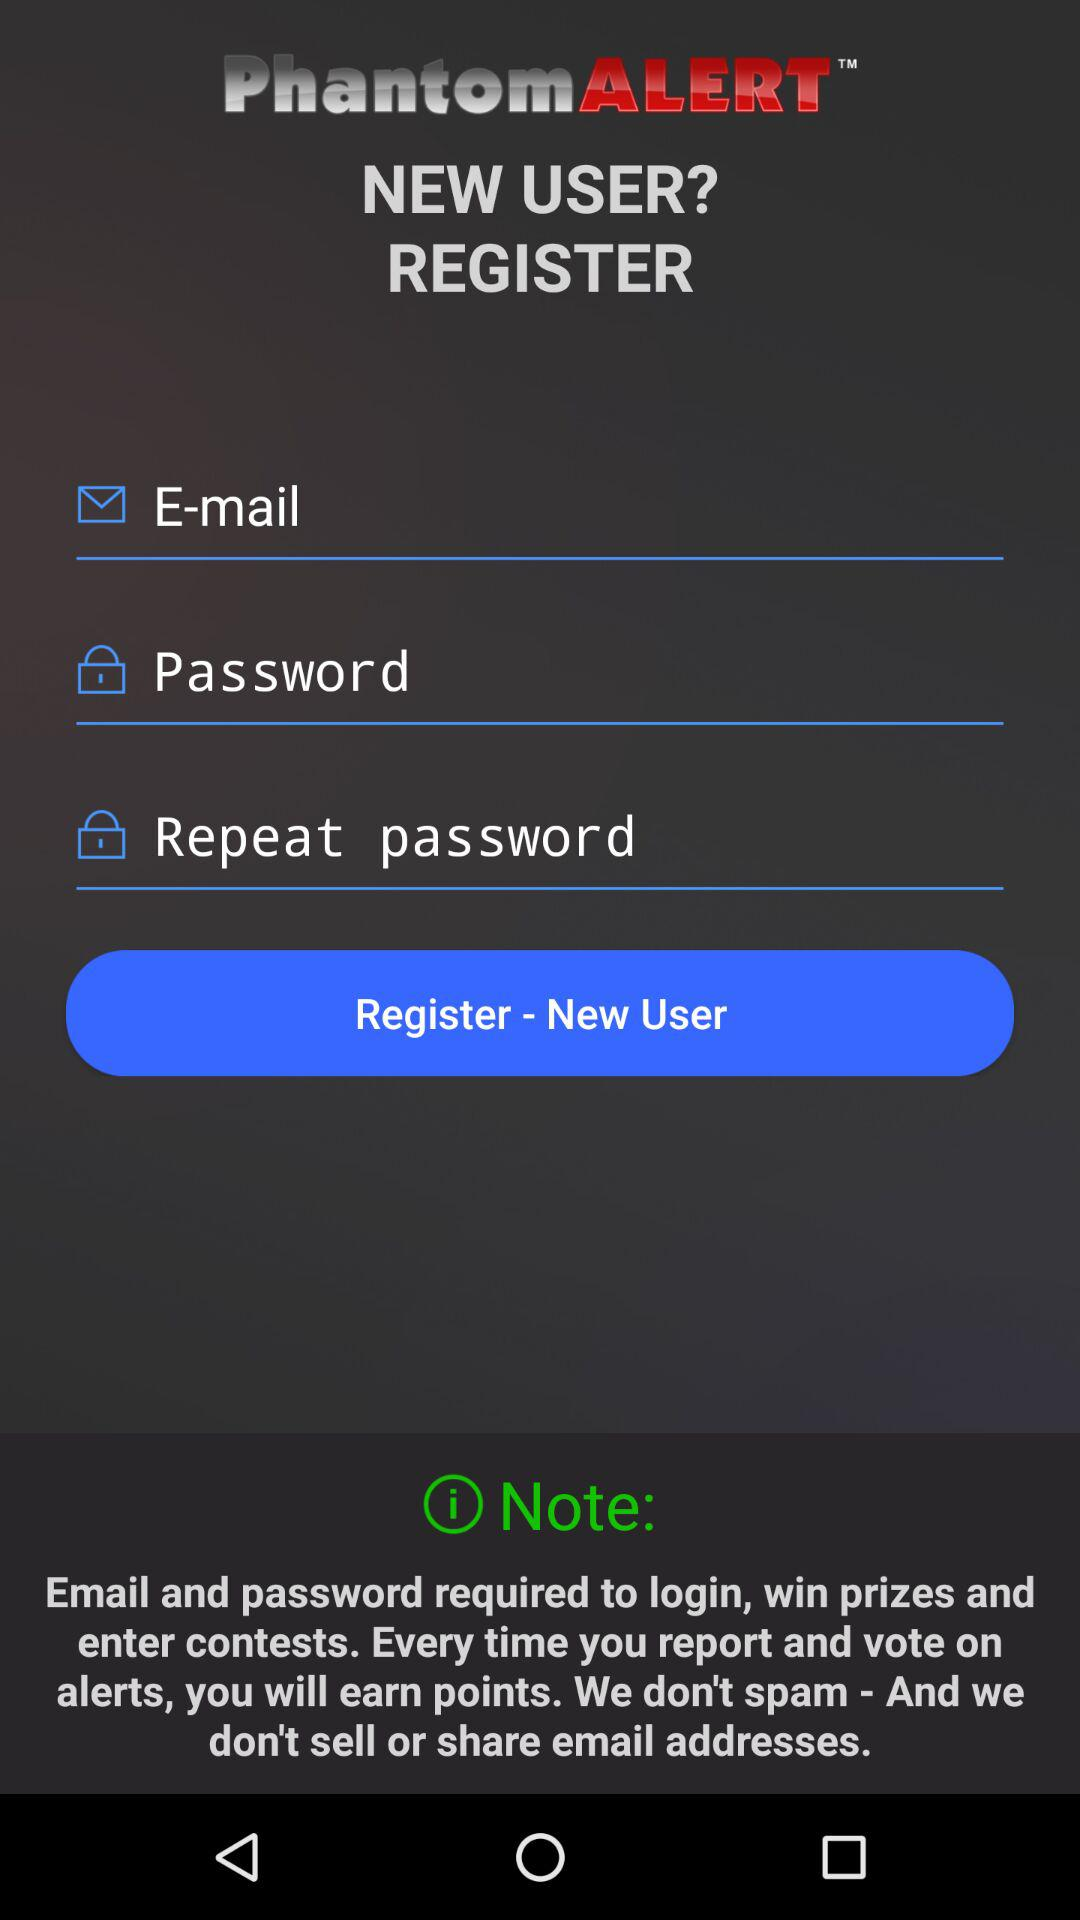What is the name of the application? The name of the application is "PhantomALERT". 